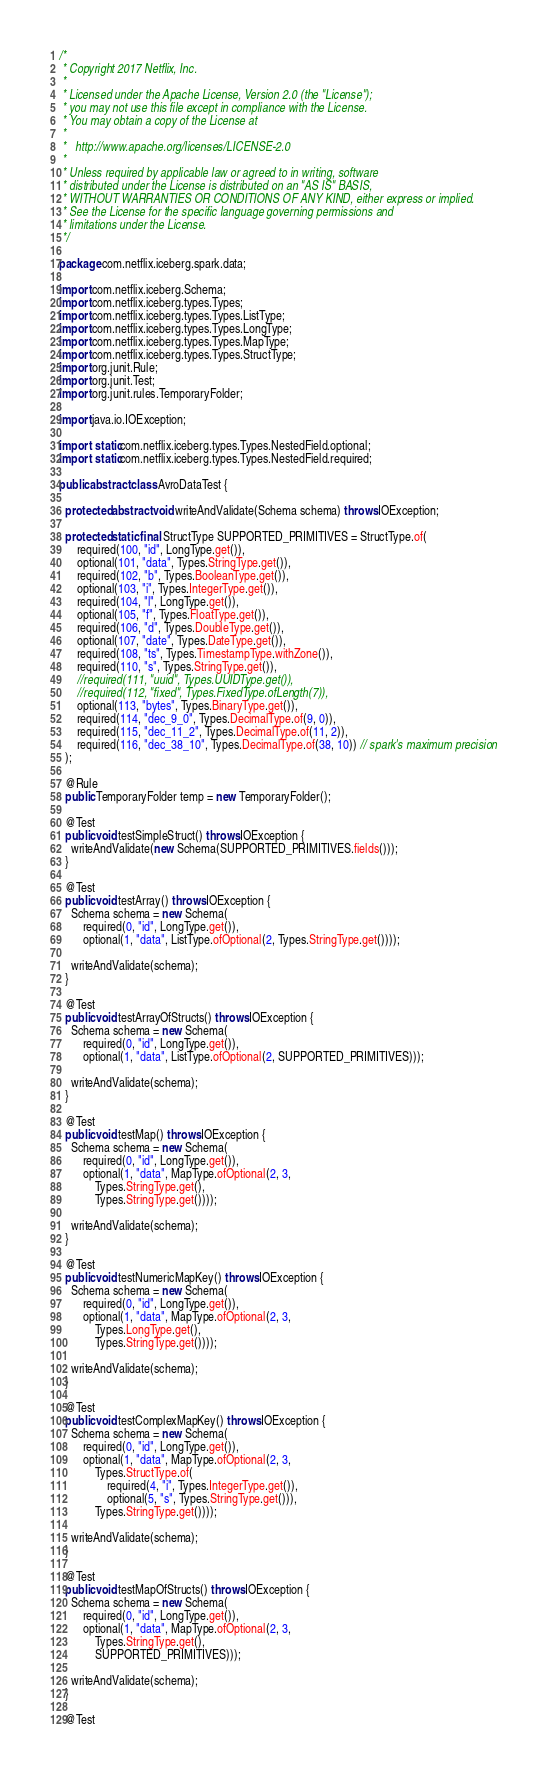Convert code to text. <code><loc_0><loc_0><loc_500><loc_500><_Java_>/*
 * Copyright 2017 Netflix, Inc.
 *
 * Licensed under the Apache License, Version 2.0 (the "License");
 * you may not use this file except in compliance with the License.
 * You may obtain a copy of the License at
 *
 *   http://www.apache.org/licenses/LICENSE-2.0
 *
 * Unless required by applicable law or agreed to in writing, software
 * distributed under the License is distributed on an "AS IS" BASIS,
 * WITHOUT WARRANTIES OR CONDITIONS OF ANY KIND, either express or implied.
 * See the License for the specific language governing permissions and
 * limitations under the License.
 */

package com.netflix.iceberg.spark.data;

import com.netflix.iceberg.Schema;
import com.netflix.iceberg.types.Types;
import com.netflix.iceberg.types.Types.ListType;
import com.netflix.iceberg.types.Types.LongType;
import com.netflix.iceberg.types.Types.MapType;
import com.netflix.iceberg.types.Types.StructType;
import org.junit.Rule;
import org.junit.Test;
import org.junit.rules.TemporaryFolder;

import java.io.IOException;

import static com.netflix.iceberg.types.Types.NestedField.optional;
import static com.netflix.iceberg.types.Types.NestedField.required;

public abstract class AvroDataTest {

  protected abstract void writeAndValidate(Schema schema) throws IOException;

  protected static final StructType SUPPORTED_PRIMITIVES = StructType.of(
      required(100, "id", LongType.get()),
      optional(101, "data", Types.StringType.get()),
      required(102, "b", Types.BooleanType.get()),
      optional(103, "i", Types.IntegerType.get()),
      required(104, "l", LongType.get()),
      optional(105, "f", Types.FloatType.get()),
      required(106, "d", Types.DoubleType.get()),
      optional(107, "date", Types.DateType.get()),
      required(108, "ts", Types.TimestampType.withZone()),
      required(110, "s", Types.StringType.get()),
      //required(111, "uuid", Types.UUIDType.get()),
      //required(112, "fixed", Types.FixedType.ofLength(7)),
      optional(113, "bytes", Types.BinaryType.get()),
      required(114, "dec_9_0", Types.DecimalType.of(9, 0)),
      required(115, "dec_11_2", Types.DecimalType.of(11, 2)),
      required(116, "dec_38_10", Types.DecimalType.of(38, 10)) // spark's maximum precision
  );

  @Rule
  public TemporaryFolder temp = new TemporaryFolder();

  @Test
  public void testSimpleStruct() throws IOException {
    writeAndValidate(new Schema(SUPPORTED_PRIMITIVES.fields()));
  }

  @Test
  public void testArray() throws IOException {
    Schema schema = new Schema(
        required(0, "id", LongType.get()),
        optional(1, "data", ListType.ofOptional(2, Types.StringType.get())));

    writeAndValidate(schema);
  }

  @Test
  public void testArrayOfStructs() throws IOException {
    Schema schema = new Schema(
        required(0, "id", LongType.get()),
        optional(1, "data", ListType.ofOptional(2, SUPPORTED_PRIMITIVES)));

    writeAndValidate(schema);
  }

  @Test
  public void testMap() throws IOException {
    Schema schema = new Schema(
        required(0, "id", LongType.get()),
        optional(1, "data", MapType.ofOptional(2, 3,
            Types.StringType.get(),
            Types.StringType.get())));

    writeAndValidate(schema);
  }

  @Test
  public void testNumericMapKey() throws IOException {
    Schema schema = new Schema(
        required(0, "id", LongType.get()),
        optional(1, "data", MapType.ofOptional(2, 3,
            Types.LongType.get(),
            Types.StringType.get())));

    writeAndValidate(schema);
  }

  @Test
  public void testComplexMapKey() throws IOException {
    Schema schema = new Schema(
        required(0, "id", LongType.get()),
        optional(1, "data", MapType.ofOptional(2, 3,
            Types.StructType.of(
                required(4, "i", Types.IntegerType.get()),
                optional(5, "s", Types.StringType.get())),
            Types.StringType.get())));

    writeAndValidate(schema);
  }

  @Test
  public void testMapOfStructs() throws IOException {
    Schema schema = new Schema(
        required(0, "id", LongType.get()),
        optional(1, "data", MapType.ofOptional(2, 3,
            Types.StringType.get(),
            SUPPORTED_PRIMITIVES)));

    writeAndValidate(schema);
  }

  @Test</code> 